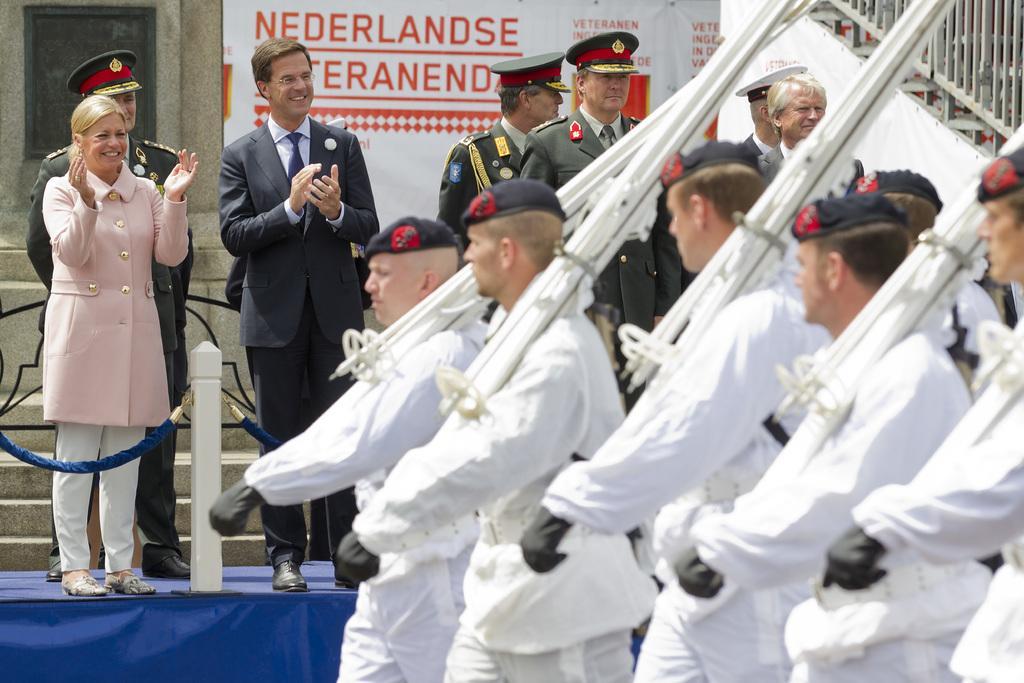How would you summarize this image in a sentence or two? In the picture we can see a man and a woman are standing on the stage, the stage is with blue color curtain and railing and behind man and woman we can see three police men are standing with uniforms and in front of them we can see some people are walking holding white color stands and they are in white dresses and in the background we can see a wall with a banner and beside it we can see a railing with steps. 